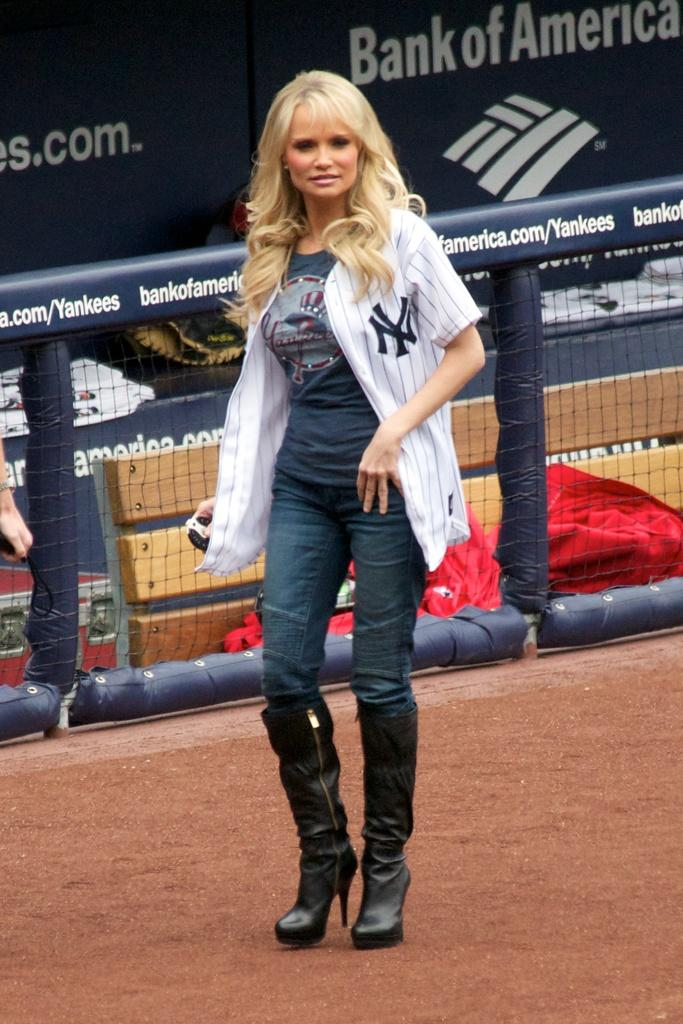<image>
Create a compact narrative representing the image presented. THE DUGOUT HAS BANK OF AMERICA AS A SPONSER. 